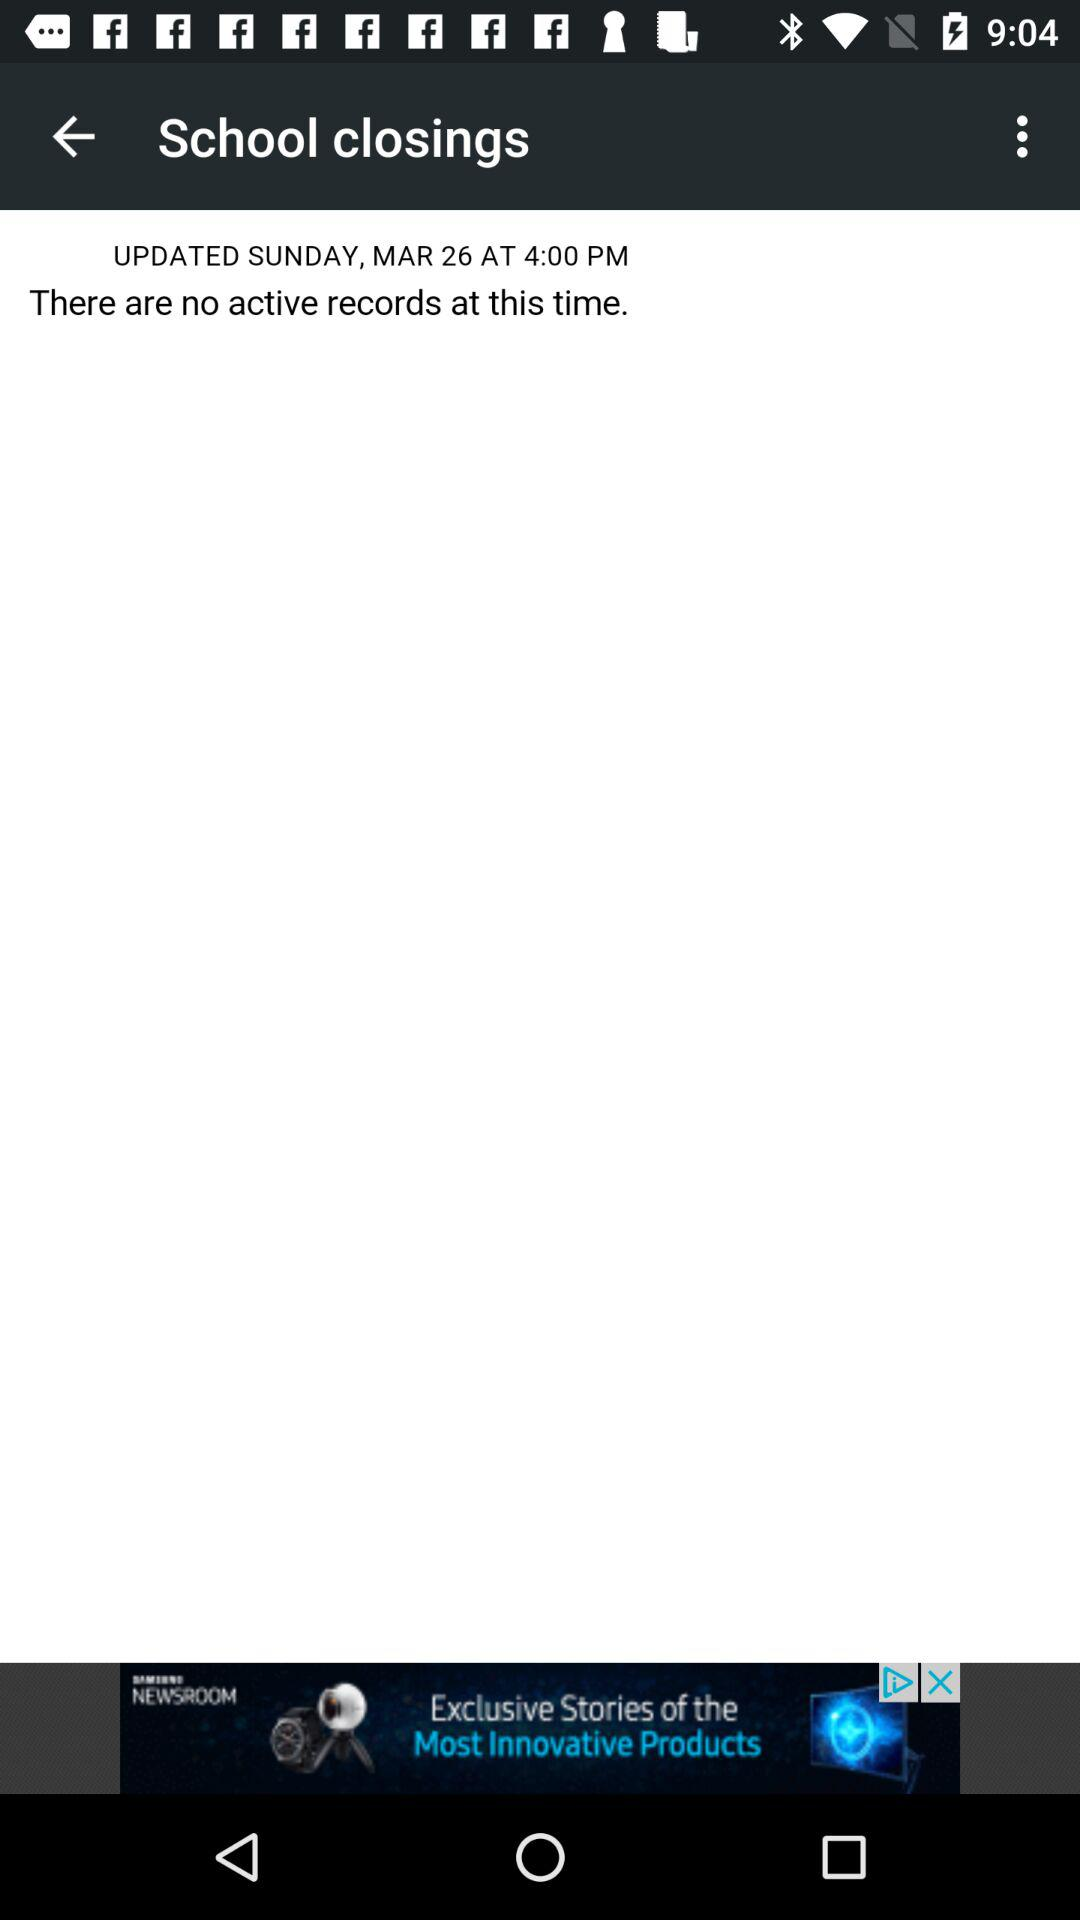When was the last record updated? The last record was updated on Sunday, March 26 at 4:00 p.m. 